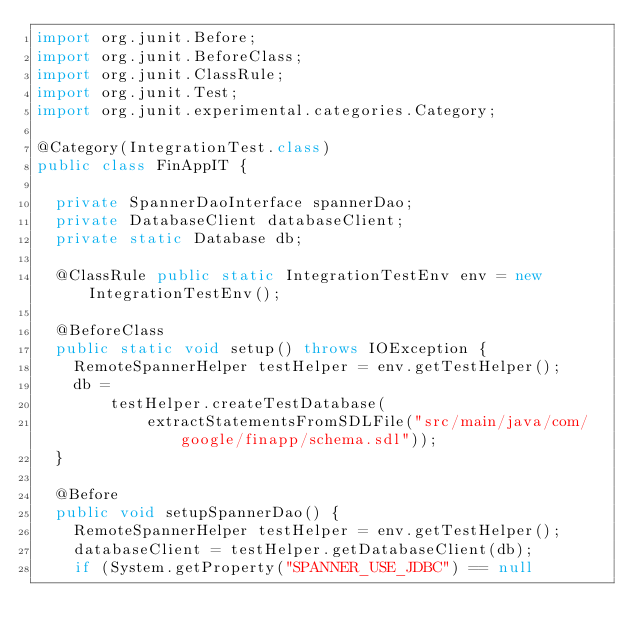<code> <loc_0><loc_0><loc_500><loc_500><_Java_>import org.junit.Before;
import org.junit.BeforeClass;
import org.junit.ClassRule;
import org.junit.Test;
import org.junit.experimental.categories.Category;

@Category(IntegrationTest.class)
public class FinAppIT {

  private SpannerDaoInterface spannerDao;
  private DatabaseClient databaseClient;
  private static Database db;

  @ClassRule public static IntegrationTestEnv env = new IntegrationTestEnv();

  @BeforeClass
  public static void setup() throws IOException {
    RemoteSpannerHelper testHelper = env.getTestHelper();
    db =
        testHelper.createTestDatabase(
            extractStatementsFromSDLFile("src/main/java/com/google/finapp/schema.sdl"));
  }

  @Before
  public void setupSpannerDao() {
    RemoteSpannerHelper testHelper = env.getTestHelper();
    databaseClient = testHelper.getDatabaseClient(db);
    if (System.getProperty("SPANNER_USE_JDBC") == null</code> 